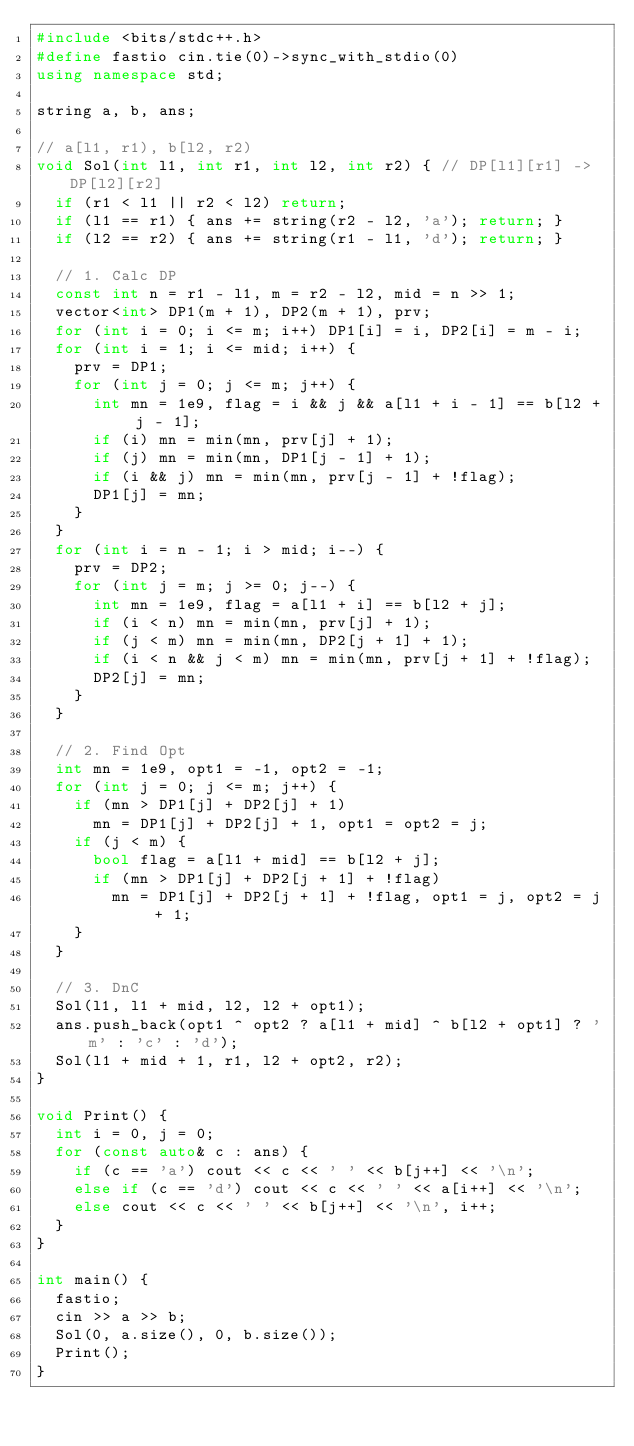<code> <loc_0><loc_0><loc_500><loc_500><_C++_>#include <bits/stdc++.h>
#define fastio cin.tie(0)->sync_with_stdio(0)
using namespace std;

string a, b, ans;

// a[l1, r1), b[l2, r2)
void Sol(int l1, int r1, int l2, int r2) { // DP[l1][r1] -> DP[l2][r2]
	if (r1 < l1 || r2 < l2) return;
	if (l1 == r1) { ans += string(r2 - l2, 'a'); return; }
	if (l2 == r2) { ans += string(r1 - l1, 'd'); return; }

	// 1. Calc DP
	const int n = r1 - l1, m = r2 - l2, mid = n >> 1;
	vector<int> DP1(m + 1), DP2(m + 1), prv;
	for (int i = 0; i <= m; i++) DP1[i] = i, DP2[i] = m - i;
	for (int i = 1; i <= mid; i++) {
		prv = DP1;
		for (int j = 0; j <= m; j++) {
			int mn = 1e9, flag = i && j && a[l1 + i - 1] == b[l2 + j - 1];
			if (i) mn = min(mn, prv[j] + 1);
			if (j) mn = min(mn, DP1[j - 1] + 1);
			if (i && j) mn = min(mn, prv[j - 1] + !flag);
			DP1[j] = mn;
		}
	}
	for (int i = n - 1; i > mid; i--) {
		prv = DP2;
		for (int j = m; j >= 0; j--) {
			int mn = 1e9, flag = a[l1 + i] == b[l2 + j];
			if (i < n) mn = min(mn, prv[j] + 1);
			if (j < m) mn = min(mn, DP2[j + 1] + 1);
			if (i < n && j < m) mn = min(mn, prv[j + 1] + !flag);
			DP2[j] = mn;
		}
	}

	// 2. Find Opt
	int mn = 1e9, opt1 = -1, opt2 = -1;
	for (int j = 0; j <= m; j++) {
		if (mn > DP1[j] + DP2[j] + 1)
			mn = DP1[j] + DP2[j] + 1, opt1 = opt2 = j;
		if (j < m) {
			bool flag = a[l1 + mid] == b[l2 + j];
			if (mn > DP1[j] + DP2[j + 1] + !flag)
				mn = DP1[j] + DP2[j + 1] + !flag, opt1 = j, opt2 = j + 1;
		}
	}

	// 3. DnC
	Sol(l1, l1 + mid, l2, l2 + opt1);
	ans.push_back(opt1 ^ opt2 ? a[l1 + mid] ^ b[l2 + opt1] ? 'm' : 'c' : 'd');
	Sol(l1 + mid + 1, r1, l2 + opt2, r2);
}

void Print() {
	int i = 0, j = 0;
	for (const auto& c : ans) {
		if (c == 'a') cout << c << ' ' << b[j++] << '\n';
		else if (c == 'd') cout << c << ' ' << a[i++] << '\n';
		else cout << c << ' ' << b[j++] << '\n', i++;
	}
}

int main() {
	fastio;
	cin >> a >> b;
	Sol(0, a.size(), 0, b.size());
	Print();
}</code> 